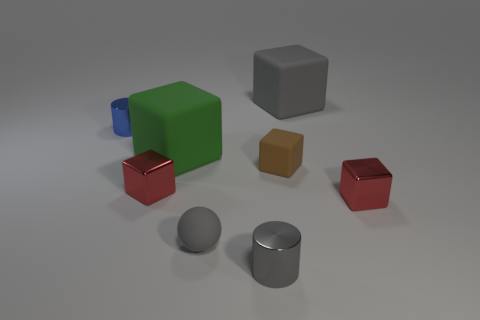Subtract 2 cubes. How many cubes are left? 3 Subtract all brown blocks. How many blocks are left? 4 Subtract all small rubber cubes. How many cubes are left? 4 Subtract all blue blocks. Subtract all purple spheres. How many blocks are left? 5 Add 1 gray rubber cubes. How many objects exist? 9 Subtract all blocks. How many objects are left? 3 Subtract all large things. Subtract all small gray rubber balls. How many objects are left? 5 Add 6 big matte objects. How many big matte objects are left? 8 Add 2 small red metallic objects. How many small red metallic objects exist? 4 Subtract 0 blue spheres. How many objects are left? 8 